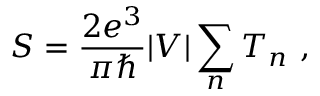<formula> <loc_0><loc_0><loc_500><loc_500>S = { \frac { 2 e ^ { 3 } } { \pi } } | V | \sum _ { n } T _ { n } \ ,</formula> 